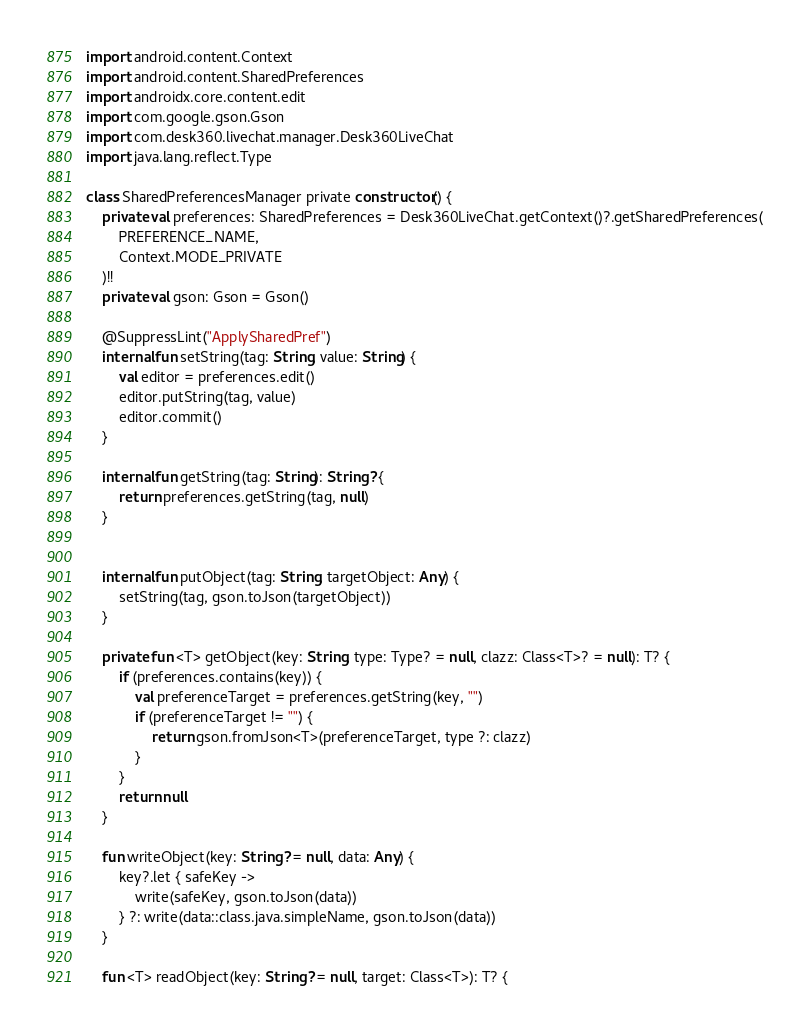<code> <loc_0><loc_0><loc_500><loc_500><_Kotlin_>import android.content.Context
import android.content.SharedPreferences
import androidx.core.content.edit
import com.google.gson.Gson
import com.desk360.livechat.manager.Desk360LiveChat
import java.lang.reflect.Type

class SharedPreferencesManager private constructor() {
    private val preferences: SharedPreferences = Desk360LiveChat.getContext()?.getSharedPreferences(
        PREFERENCE_NAME,
        Context.MODE_PRIVATE
    )!!
    private val gson: Gson = Gson()

    @SuppressLint("ApplySharedPref")
    internal fun setString(tag: String, value: String) {
        val editor = preferences.edit()
        editor.putString(tag, value)
        editor.commit()
    }

    internal fun getString(tag: String): String? {
        return preferences.getString(tag, null)
    }


    internal fun putObject(tag: String, targetObject: Any) {
        setString(tag, gson.toJson(targetObject))
    }

    private fun <T> getObject(key: String, type: Type? = null, clazz: Class<T>? = null): T? {
        if (preferences.contains(key)) {
            val preferenceTarget = preferences.getString(key, "")
            if (preferenceTarget != "") {
                return gson.fromJson<T>(preferenceTarget, type ?: clazz)
            }
        }
        return null
    }

    fun writeObject(key: String? = null, data: Any) {
        key?.let { safeKey ->
            write(safeKey, gson.toJson(data))
        } ?: write(data::class.java.simpleName, gson.toJson(data))
    }

    fun <T> readObject(key: String? = null, target: Class<T>): T? {</code> 